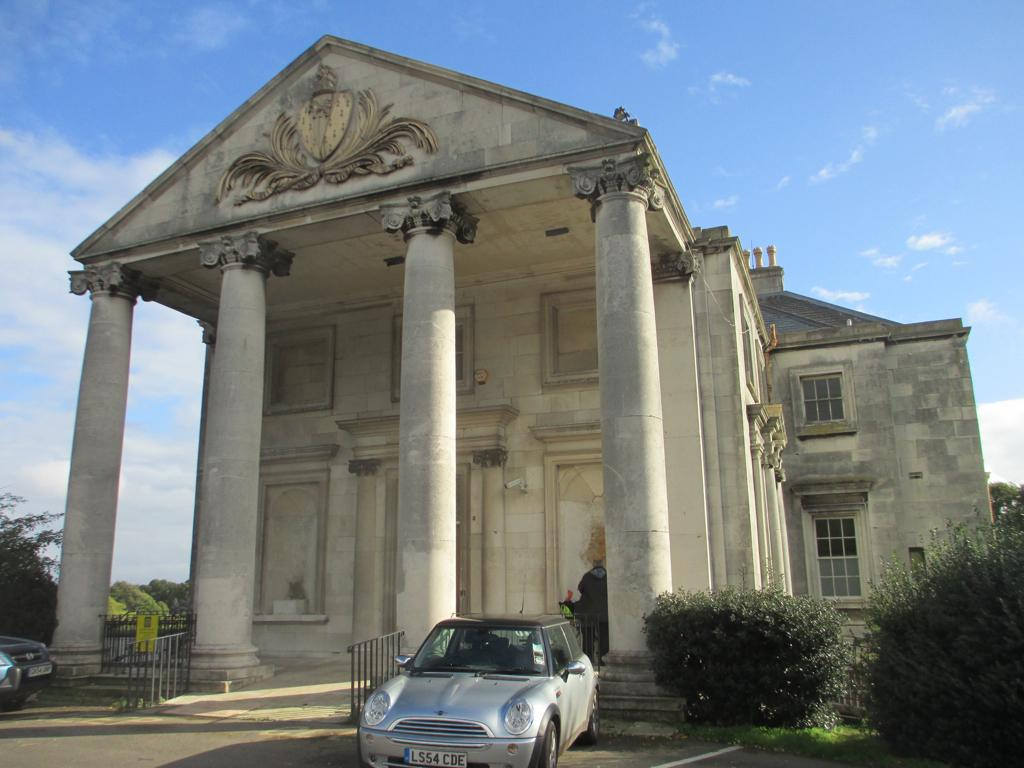What type of structure can be seen in the background of the image? There is a building in the background of the image. What can be seen in the sky in the background of the image? The sky is visible in the background of the image. What type of vegetation is present in the background of the image? There are trees in the background of the image. What is located in the foreground of the image? There is a car and a road in the foreground of the image. What type of plants are visible in the foreground of the image? There are plants in the foreground of the image. How many rats are visible on the car in the image? There are no rats present on the car in the image. What type of baby is sitting in the building in the background of the image? There is no baby present in the building in the background of the image. 